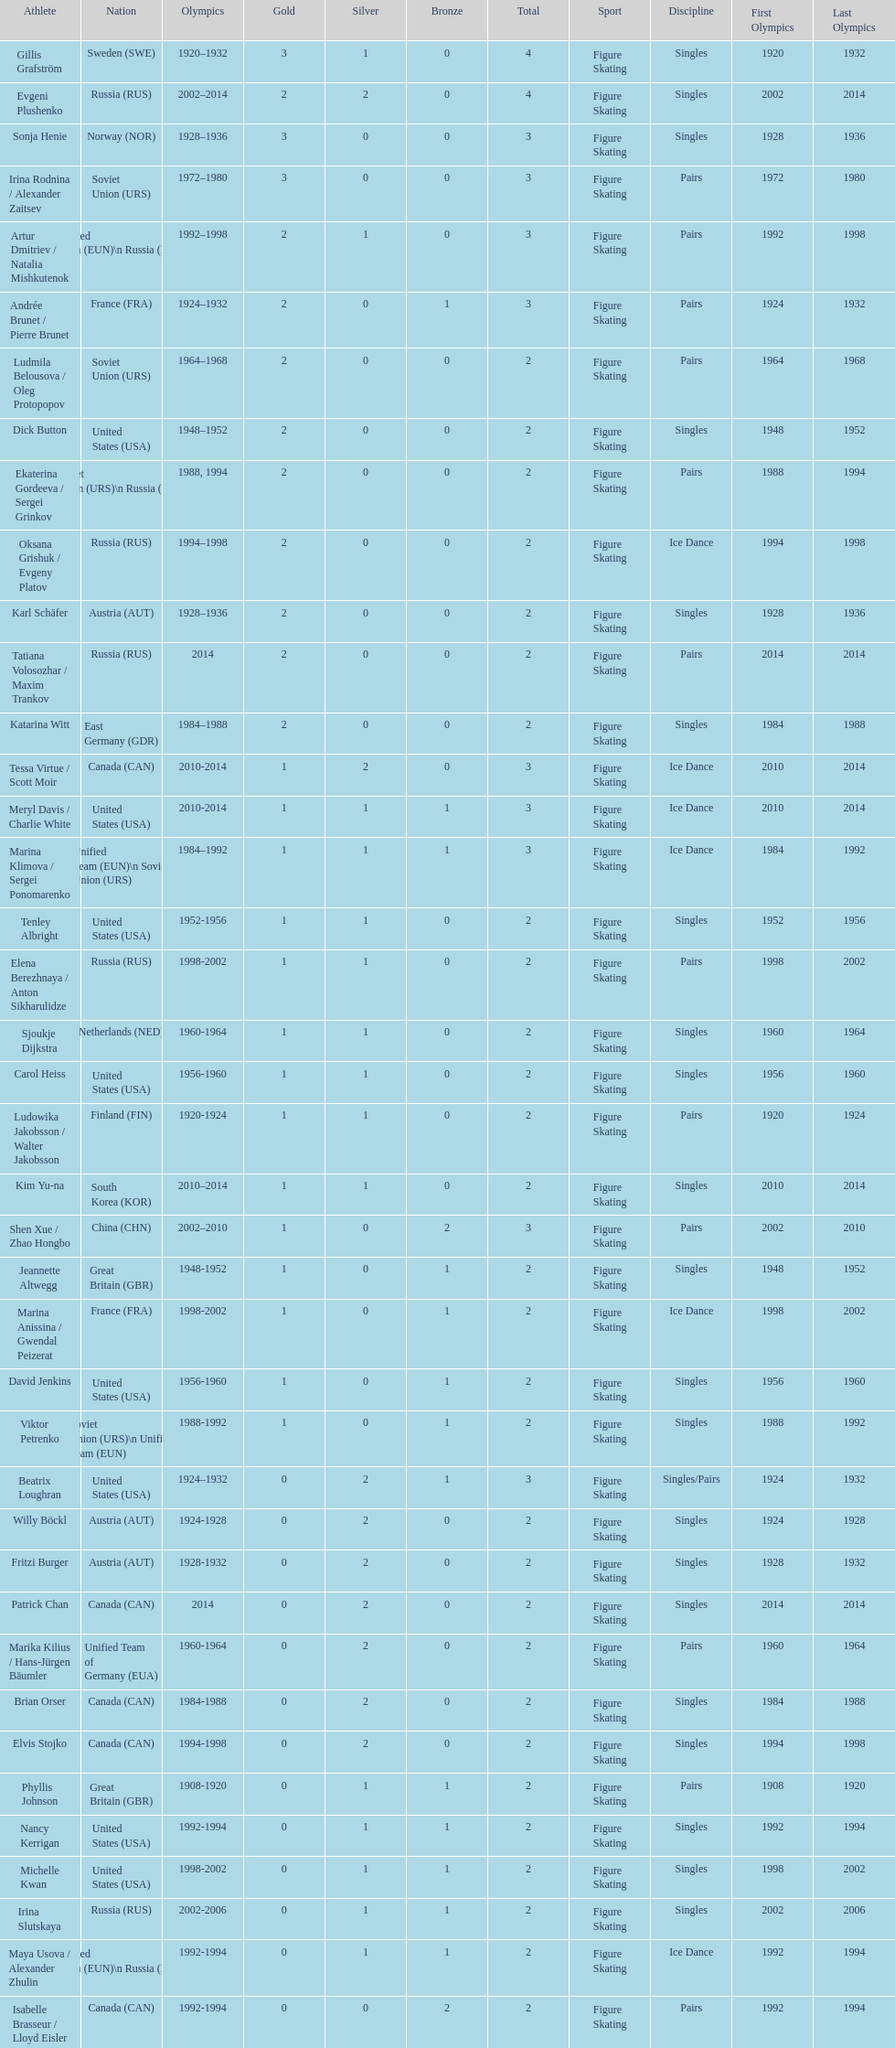How many total medals has the united states won in women's figure skating? 16. 